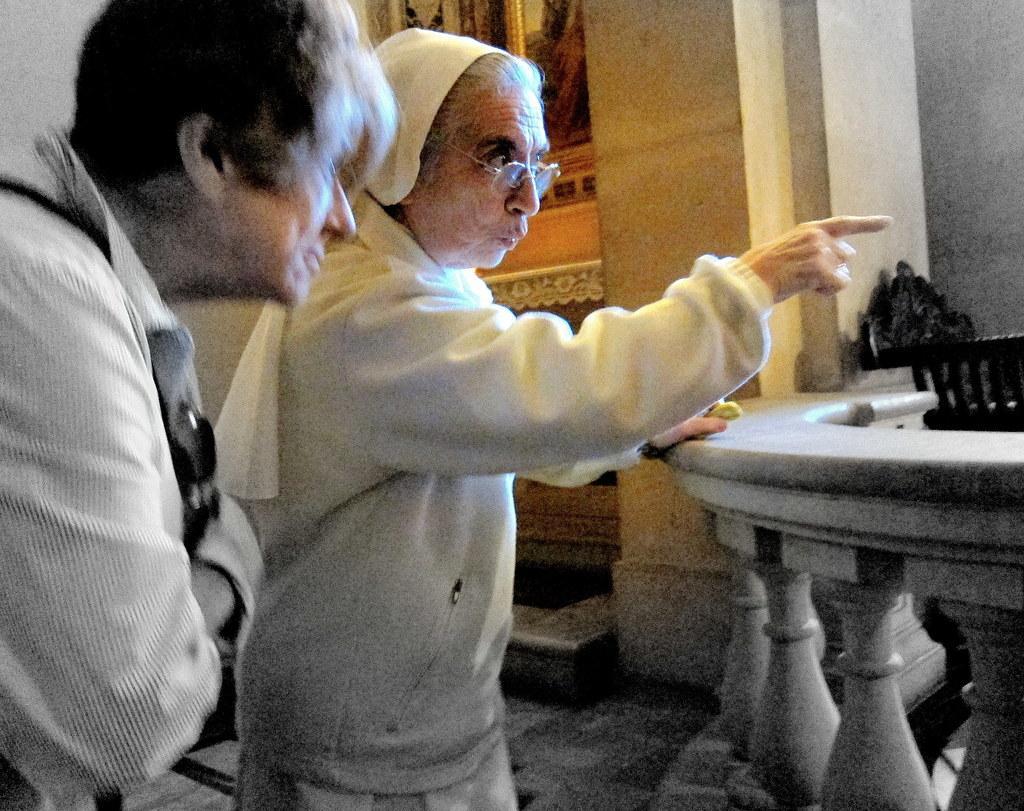Can you describe this image briefly? In this image we can see two persons. We can also see the pillar, wall and also the frame attached to the wall. On the right there is fence which is constructed with the small pillars. We can also see the floor. 